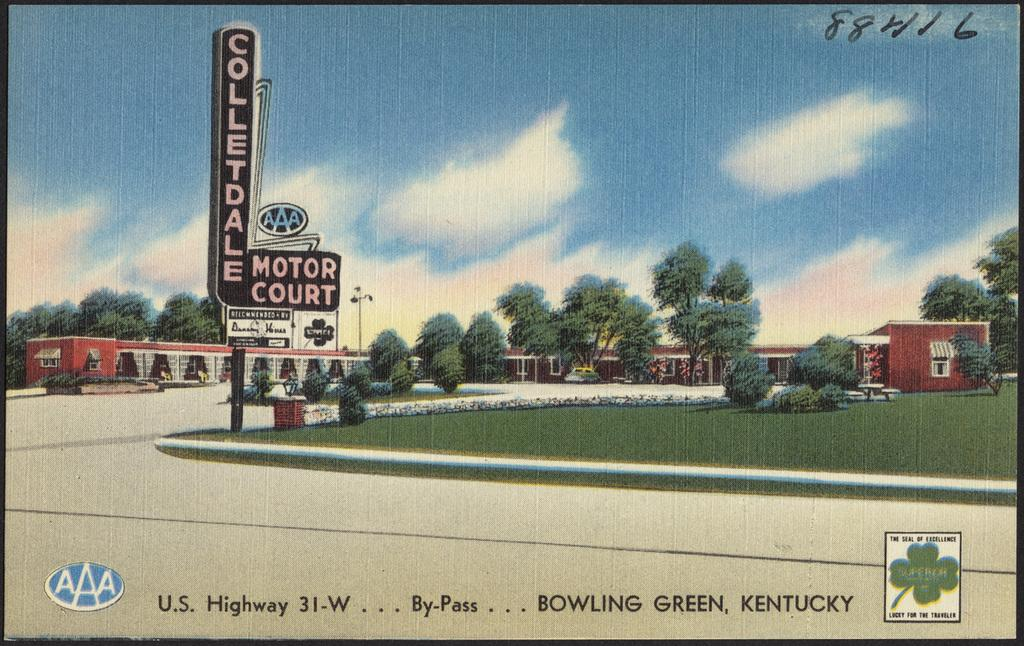Provide a one-sentence caption for the provided image. The picture is a display of business based in Bowling Green Kentucky. 